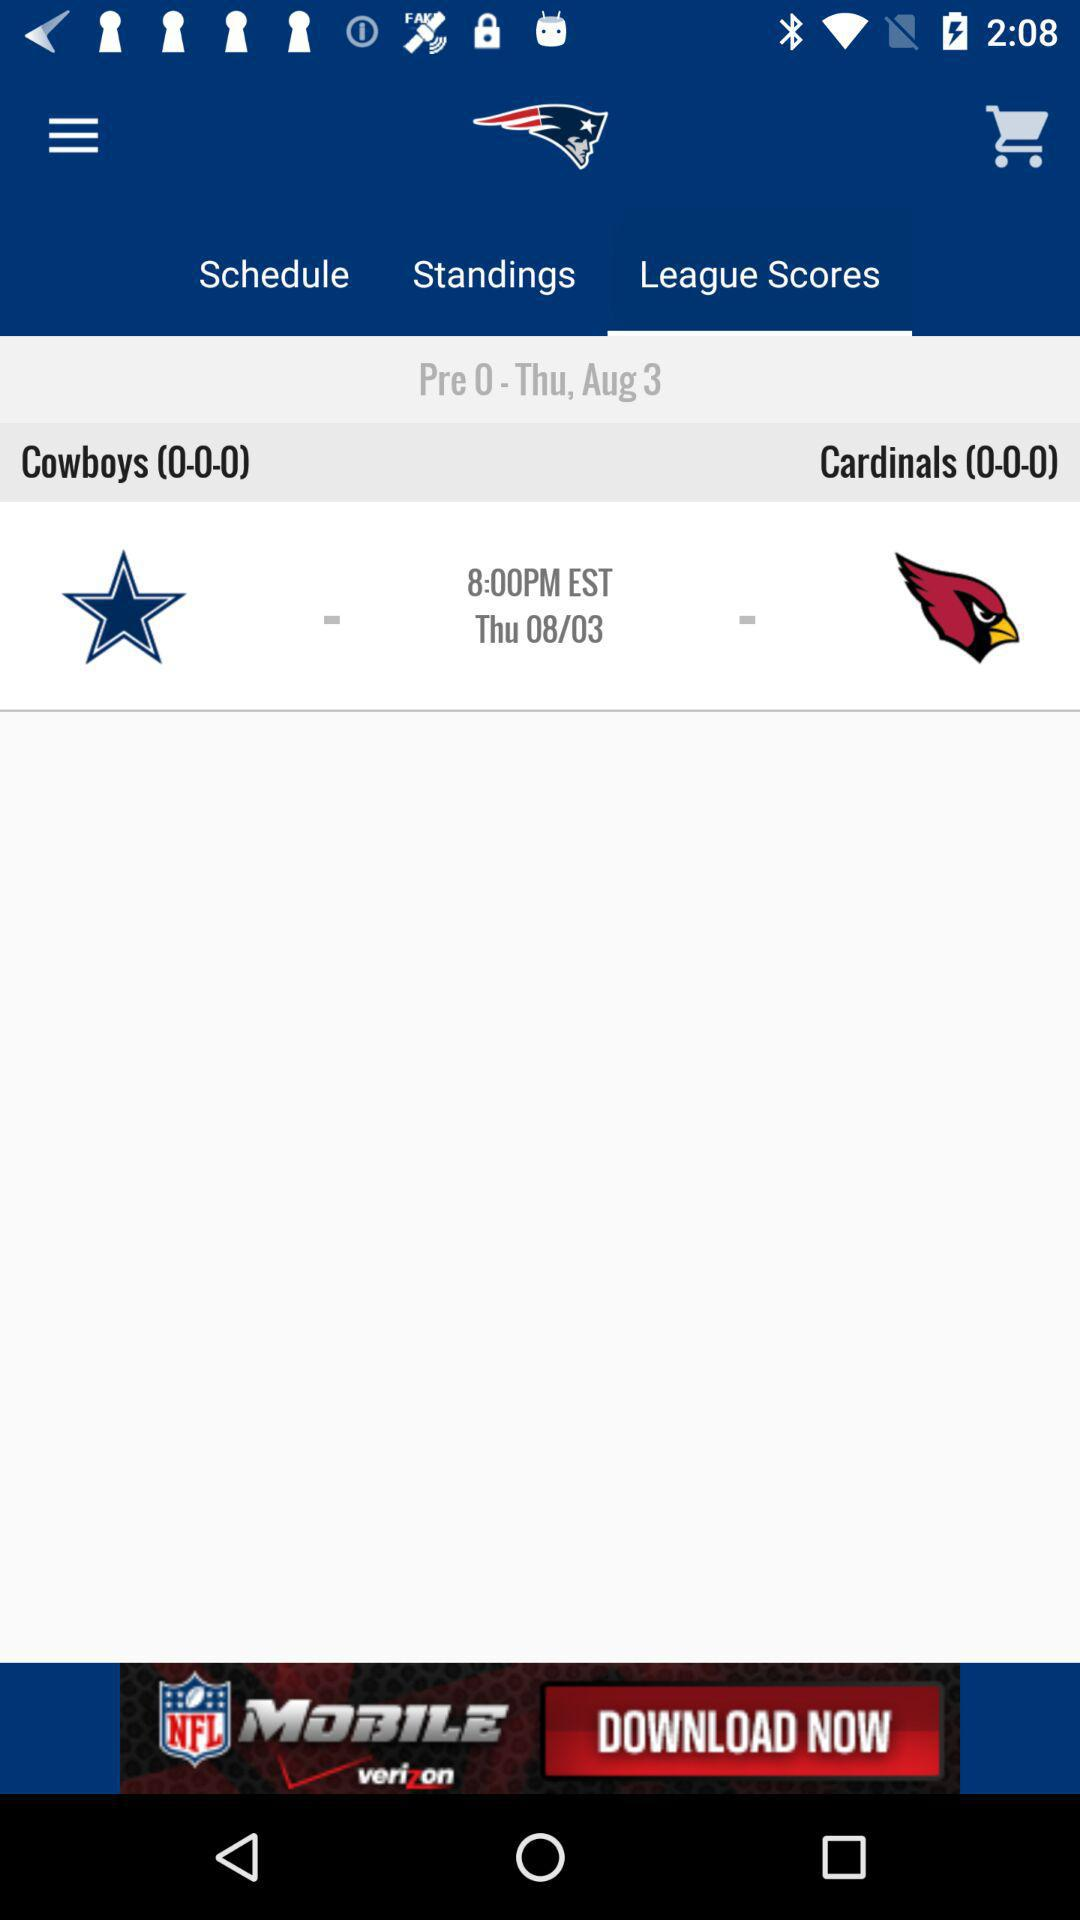How many more games does the Cardinals have played than the Cowboys?
Answer the question using a single word or phrase. 0 